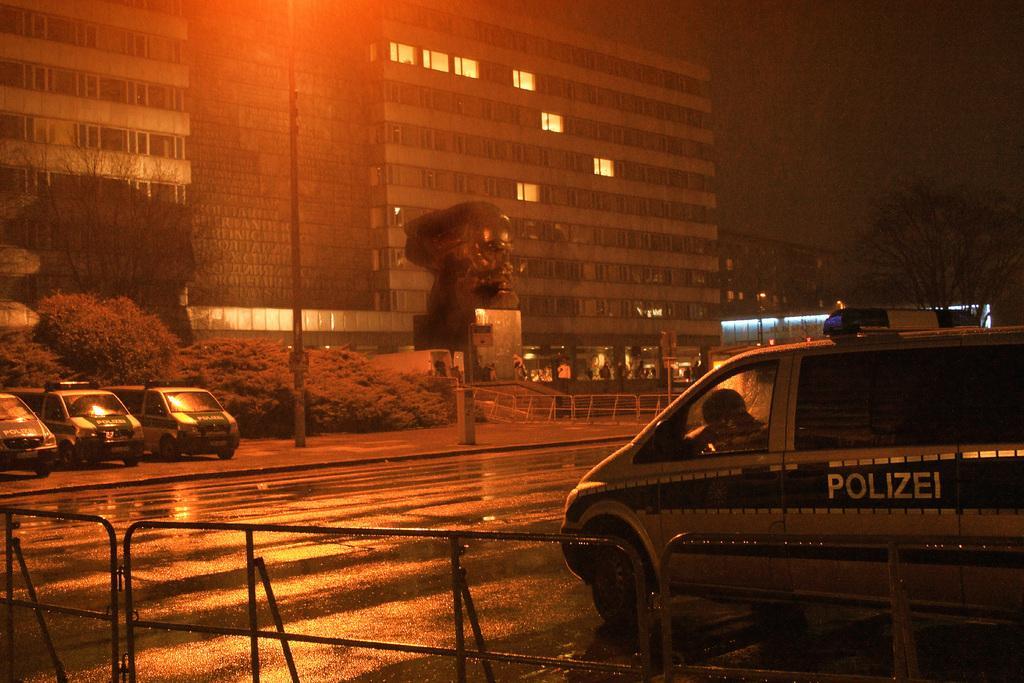How would you summarize this image in a sentence or two? Here, we can see it's raining, at the right side there is a car, on that POLICE is written, there is a road and there are some cars, there are some plants and trees and there is a building. 